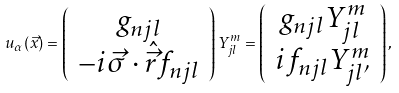<formula> <loc_0><loc_0><loc_500><loc_500>u _ { \alpha } ( \vec { x } ) = \left ( \begin{array} { c } { { g _ { n j l } } } \\ { { - i \vec { \sigma } \cdot \hat { \vec { r } } f _ { n j l } } } \end{array} \right ) Y _ { j l } ^ { m } = \left ( \begin{array} { c } { { g _ { n j l } Y _ { j l } ^ { m } } } \\ { { i f _ { n j l } Y _ { j l ^ { \prime } } ^ { m } } } \end{array} \right ) ,</formula> 